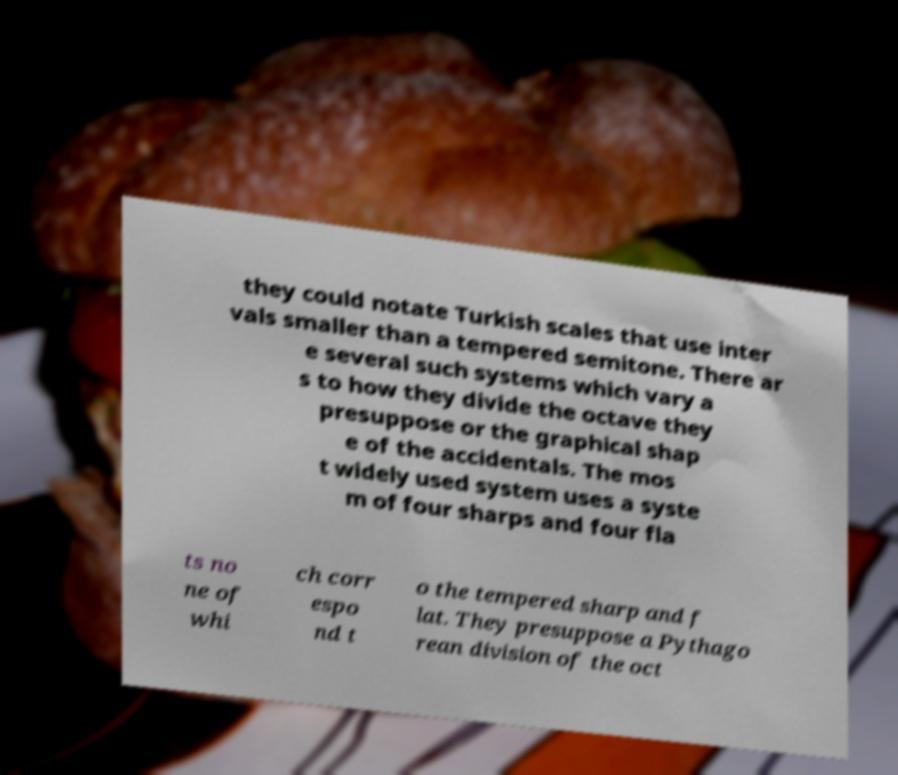Could you extract and type out the text from this image? they could notate Turkish scales that use inter vals smaller than a tempered semitone. There ar e several such systems which vary a s to how they divide the octave they presuppose or the graphical shap e of the accidentals. The mos t widely used system uses a syste m of four sharps and four fla ts no ne of whi ch corr espo nd t o the tempered sharp and f lat. They presuppose a Pythago rean division of the oct 